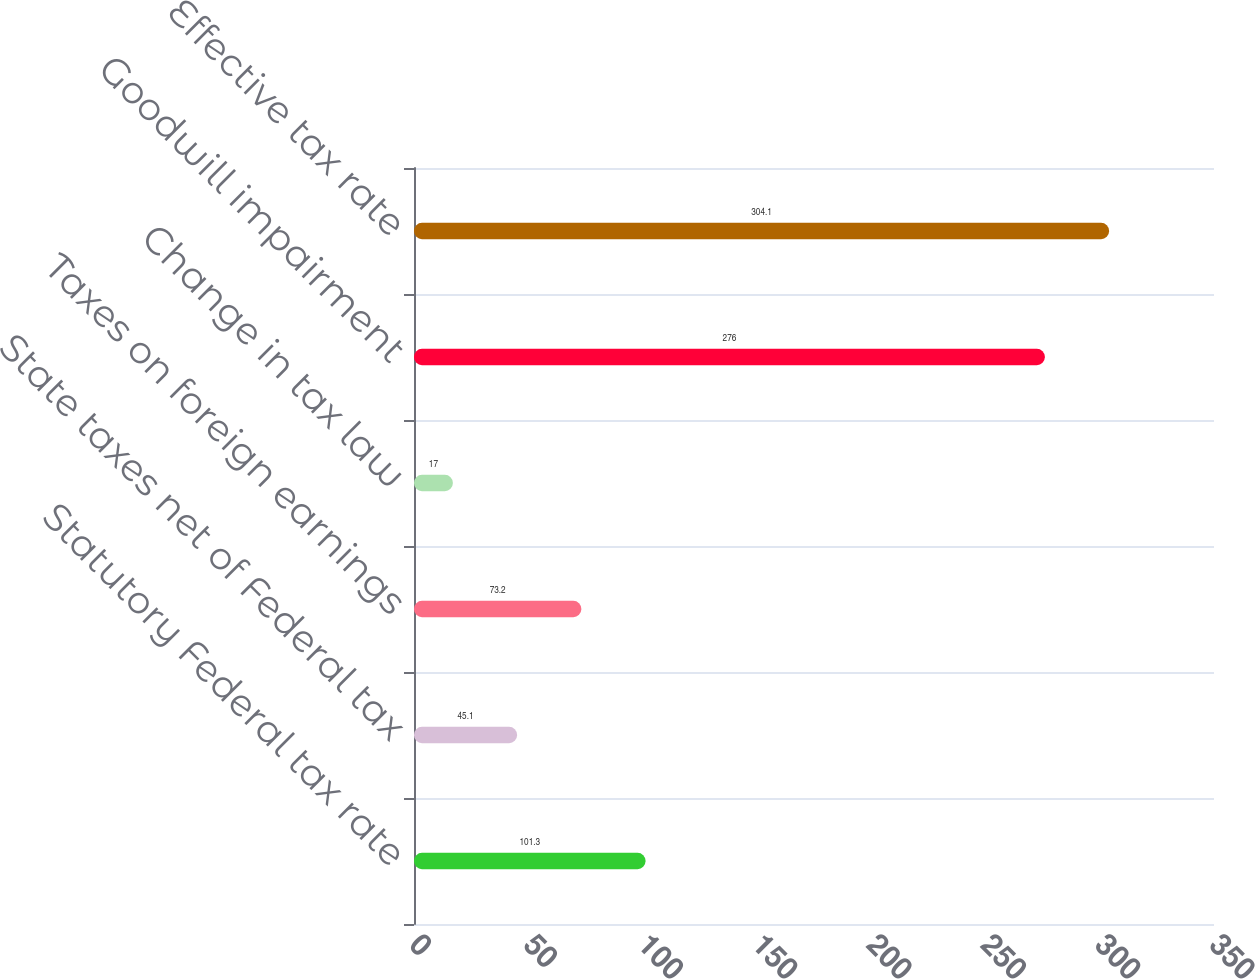Convert chart to OTSL. <chart><loc_0><loc_0><loc_500><loc_500><bar_chart><fcel>Statutory Federal tax rate<fcel>State taxes net of Federal tax<fcel>Taxes on foreign earnings<fcel>Change in tax law<fcel>Goodwill impairment<fcel>Effective tax rate<nl><fcel>101.3<fcel>45.1<fcel>73.2<fcel>17<fcel>276<fcel>304.1<nl></chart> 